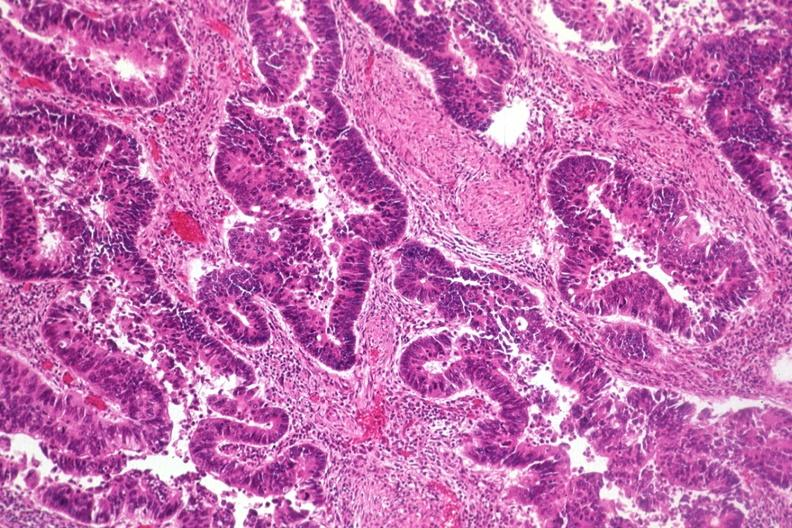s alpha smooth muscle actin immunohistochemical present?
Answer the question using a single word or phrase. No 